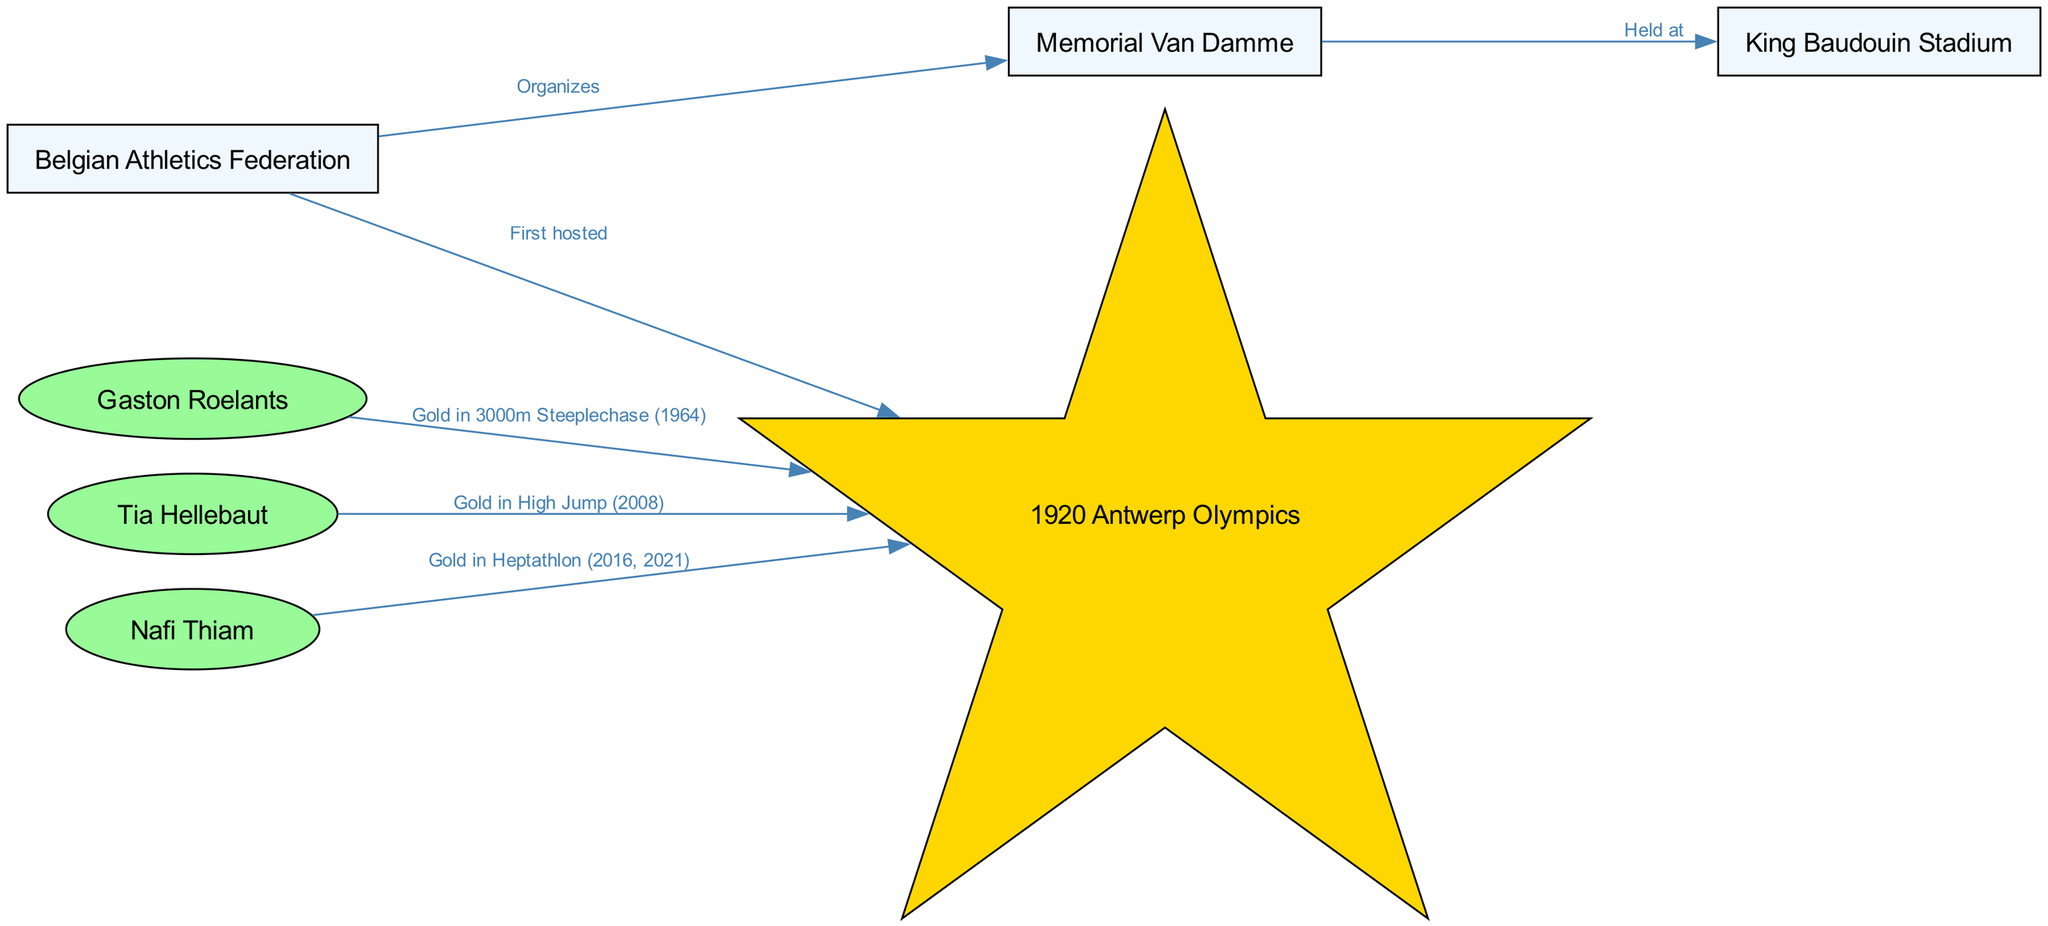What organization organizes the Memorial Van Damme? The diagram shows a directed edge labeled "Organizes" leading from the "Belgian Athletics Federation" node to the "Memorial Van Damme" node, indicating that this organization is responsible for the event.
Answer: Belgian Athletics Federation How many gold medals did Gaston Roelants win at the 1920 Antwerp Olympics? The diagram does not specify the number of medals Gaston Roelants won, but it states he earned a gold medal in the 3000m steeplechase in 1964 at the Olympics, showing a connection between Roelants and the Olympics without specifying other medals.
Answer: 1 What is the relationship between Tia Hellebaut and the 1920 Antwerp Olympics? The diagram shows Tia Hellebaut connected to the 1920 Antwerp Olympics indirectly through her gold medal in high jump listed separately in 2008, meaning there is no direct relationship for her concerning these specific Olympics.
Answer: None Which stadium hosts the Memorial Van Damme? The diagram illustrates an edge labeled "Held at" going from "Memorial Van Damme" to "King Baudouin Stadium," indicating that the event takes place at this stadium.
Answer: King Baudouin Stadium What year did Nafi Thiam win gold medals at the Olympics? The diagram notes that Nafi Thiam won gold in the heptathlon at the Olympics in two specific years: 2016 and 2021, providing direct information regarding her achievements.
Answer: 2016, 2021 What type of node style is used for Olympic events in this diagram? In the diagram, the node representing the Olympics (1920 Antwerp Olympics) is styled as a star, indicated by the special shape and fill color as shown in the formatting instructions, distinguishing it from other nodes.
Answer: Star How many athletes are depicted in the diagram? The nodes mentioned as athletes include Gaston Roelants, Tia Hellebaut, and Nafi Thiam, thus the diagram contains three athlete nodes based on the provided data.
Answer: 3 What is the first athletic event hosted by the Belgian Athletics Federation? According to the diagram, the Belgian Athletics Federation has a directed edge labeled "First hosted" leading to the "1920 Antwerp Olympics," indicating this was the inaugural event organized by them.
Answer: 1920 Antwerp Olympics Which athlete won a gold medal in the 3000m steeplechase? The diagram clearly indicates that Gaston Roelants won gold in the 3000m steeplechase event at the 1964 Olympics, providing a direct connection between the athlete and the event.
Answer: Gaston Roelants 